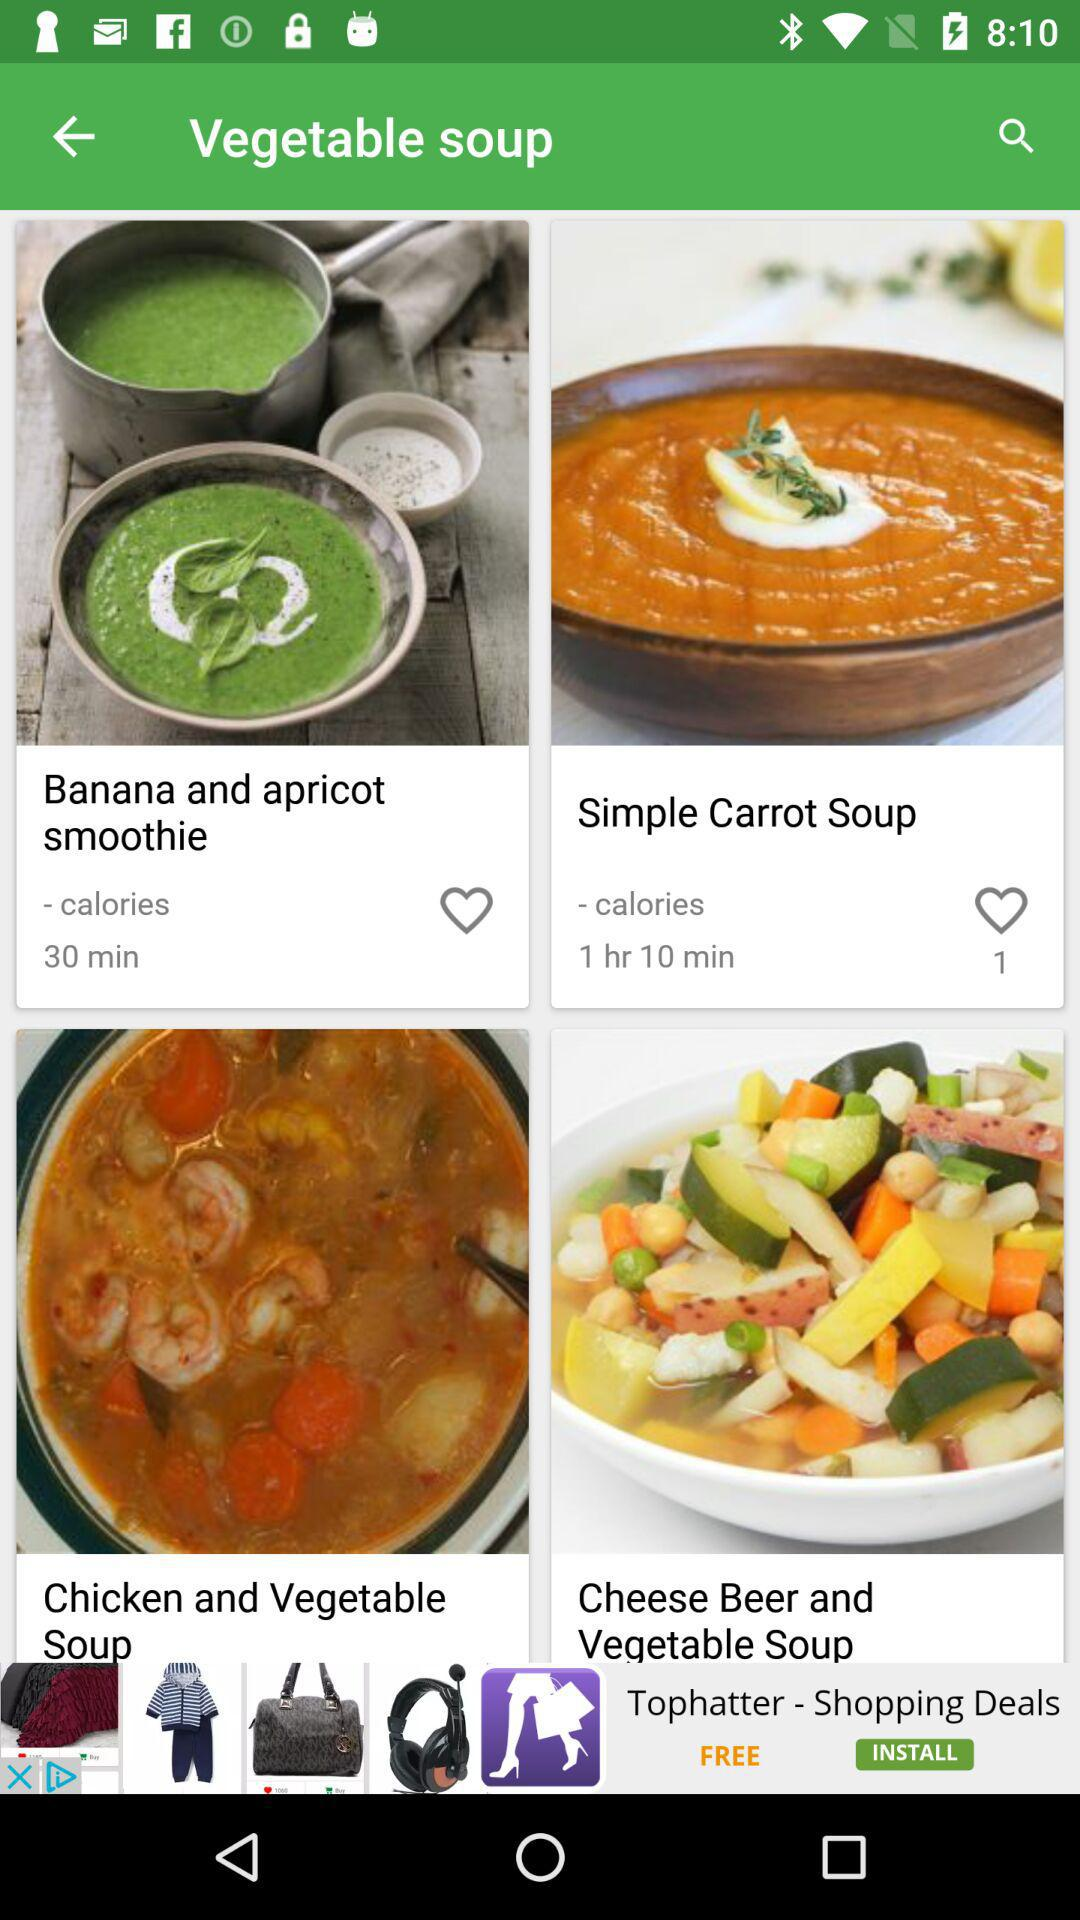How much time will it take to make the banana and apricot smoothie?
When the provided information is insufficient, respond with <no answer>. <no answer> 